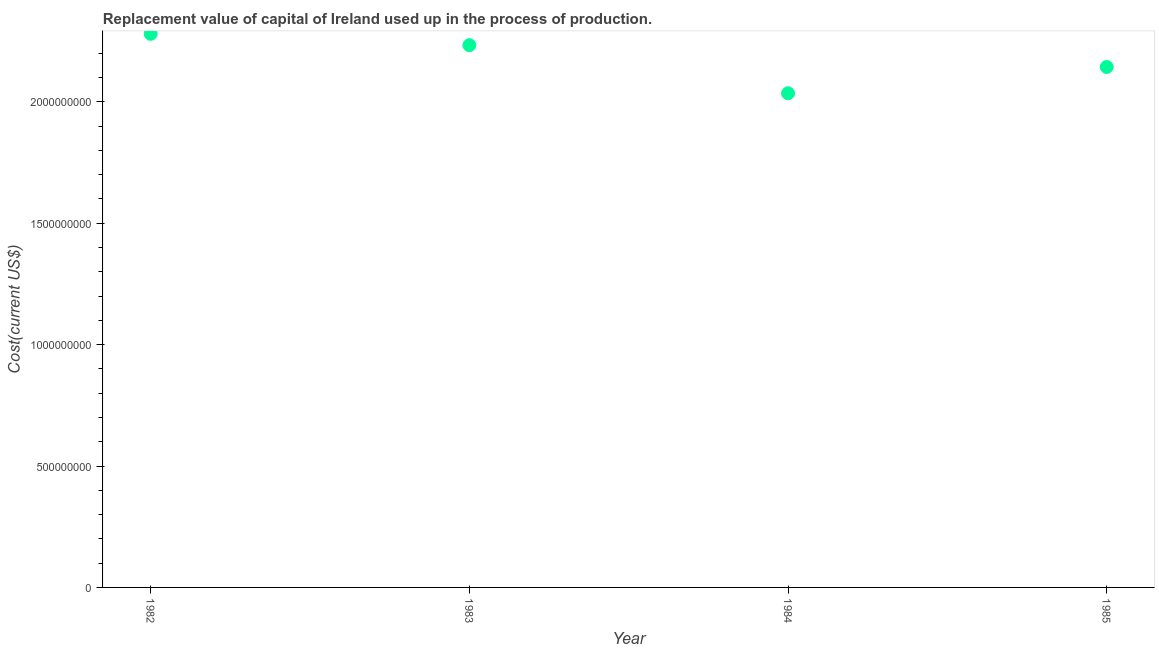What is the consumption of fixed capital in 1984?
Make the answer very short. 2.04e+09. Across all years, what is the maximum consumption of fixed capital?
Offer a very short reply. 2.28e+09. Across all years, what is the minimum consumption of fixed capital?
Give a very brief answer. 2.04e+09. In which year was the consumption of fixed capital maximum?
Your answer should be very brief. 1982. What is the sum of the consumption of fixed capital?
Make the answer very short. 8.69e+09. What is the difference between the consumption of fixed capital in 1983 and 1985?
Provide a succinct answer. 8.97e+07. What is the average consumption of fixed capital per year?
Keep it short and to the point. 2.17e+09. What is the median consumption of fixed capital?
Ensure brevity in your answer.  2.19e+09. In how many years, is the consumption of fixed capital greater than 700000000 US$?
Keep it short and to the point. 4. Do a majority of the years between 1985 and 1984 (inclusive) have consumption of fixed capital greater than 300000000 US$?
Offer a very short reply. No. What is the ratio of the consumption of fixed capital in 1982 to that in 1985?
Keep it short and to the point. 1.06. What is the difference between the highest and the second highest consumption of fixed capital?
Your response must be concise. 4.69e+07. What is the difference between the highest and the lowest consumption of fixed capital?
Keep it short and to the point. 2.45e+08. How many dotlines are there?
Your response must be concise. 1. How many years are there in the graph?
Your answer should be very brief. 4. What is the difference between two consecutive major ticks on the Y-axis?
Provide a succinct answer. 5.00e+08. Does the graph contain any zero values?
Offer a very short reply. No. Does the graph contain grids?
Make the answer very short. No. What is the title of the graph?
Your answer should be very brief. Replacement value of capital of Ireland used up in the process of production. What is the label or title of the X-axis?
Keep it short and to the point. Year. What is the label or title of the Y-axis?
Provide a succinct answer. Cost(current US$). What is the Cost(current US$) in 1982?
Your answer should be very brief. 2.28e+09. What is the Cost(current US$) in 1983?
Keep it short and to the point. 2.23e+09. What is the Cost(current US$) in 1984?
Ensure brevity in your answer.  2.04e+09. What is the Cost(current US$) in 1985?
Your answer should be compact. 2.14e+09. What is the difference between the Cost(current US$) in 1982 and 1983?
Offer a very short reply. 4.69e+07. What is the difference between the Cost(current US$) in 1982 and 1984?
Your response must be concise. 2.45e+08. What is the difference between the Cost(current US$) in 1982 and 1985?
Offer a very short reply. 1.37e+08. What is the difference between the Cost(current US$) in 1983 and 1984?
Provide a succinct answer. 1.98e+08. What is the difference between the Cost(current US$) in 1983 and 1985?
Provide a succinct answer. 8.97e+07. What is the difference between the Cost(current US$) in 1984 and 1985?
Your answer should be very brief. -1.08e+08. What is the ratio of the Cost(current US$) in 1982 to that in 1984?
Keep it short and to the point. 1.12. What is the ratio of the Cost(current US$) in 1982 to that in 1985?
Your answer should be compact. 1.06. What is the ratio of the Cost(current US$) in 1983 to that in 1984?
Your answer should be very brief. 1.1. What is the ratio of the Cost(current US$) in 1983 to that in 1985?
Your response must be concise. 1.04. What is the ratio of the Cost(current US$) in 1984 to that in 1985?
Your answer should be very brief. 0.95. 